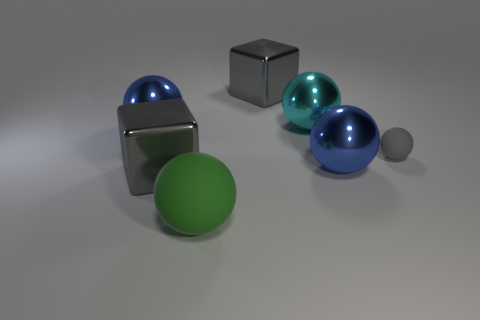Do the green rubber sphere and the gray matte sphere have the same size?
Provide a succinct answer. No. What is the color of the small thing?
Ensure brevity in your answer.  Gray. What number of things are large purple balls or tiny gray things?
Provide a short and direct response. 1. Are there any brown things that have the same shape as the green matte object?
Make the answer very short. No. There is a big metallic cube in front of the small gray object; is it the same color as the large matte thing?
Make the answer very short. No. What is the shape of the matte object to the left of the tiny matte thing to the right of the big cyan metallic thing?
Offer a very short reply. Sphere. Are there any cyan metallic objects of the same size as the green matte sphere?
Keep it short and to the point. Yes. Are there fewer big gray shiny objects than big gray cylinders?
Your response must be concise. No. What is the shape of the big blue shiny object that is to the left of the gray block that is behind the big gray metal object that is to the left of the big green matte ball?
Keep it short and to the point. Sphere. What number of things are either gray blocks that are in front of the cyan ball or big objects that are right of the cyan thing?
Offer a very short reply. 2. 